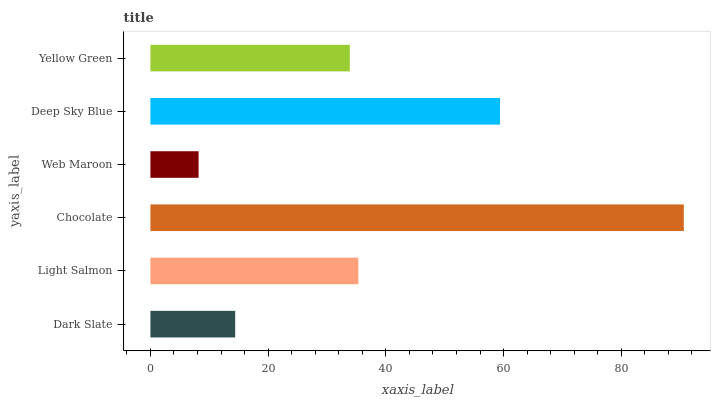Is Web Maroon the minimum?
Answer yes or no. Yes. Is Chocolate the maximum?
Answer yes or no. Yes. Is Light Salmon the minimum?
Answer yes or no. No. Is Light Salmon the maximum?
Answer yes or no. No. Is Light Salmon greater than Dark Slate?
Answer yes or no. Yes. Is Dark Slate less than Light Salmon?
Answer yes or no. Yes. Is Dark Slate greater than Light Salmon?
Answer yes or no. No. Is Light Salmon less than Dark Slate?
Answer yes or no. No. Is Light Salmon the high median?
Answer yes or no. Yes. Is Yellow Green the low median?
Answer yes or no. Yes. Is Chocolate the high median?
Answer yes or no. No. Is Chocolate the low median?
Answer yes or no. No. 